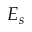<formula> <loc_0><loc_0><loc_500><loc_500>E _ { s }</formula> 